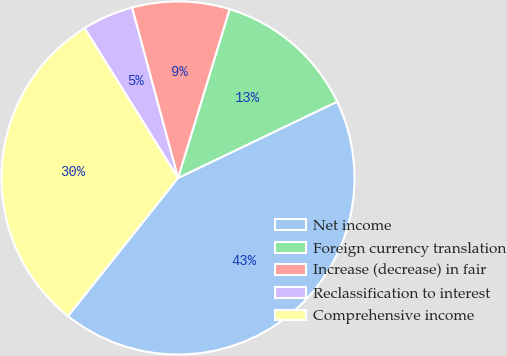<chart> <loc_0><loc_0><loc_500><loc_500><pie_chart><fcel>Net income<fcel>Foreign currency translation<fcel>Increase (decrease) in fair<fcel>Reclassification to interest<fcel>Comprehensive income<nl><fcel>42.83%<fcel>13.16%<fcel>8.92%<fcel>4.68%<fcel>30.42%<nl></chart> 